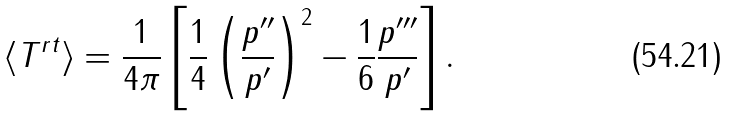<formula> <loc_0><loc_0><loc_500><loc_500>\langle T ^ { r t } \rangle = \frac { 1 } { 4 \pi } \left [ \frac { 1 } { 4 } \left ( \frac { p ^ { \prime \prime } } { p ^ { \prime } } \right ) ^ { 2 } - \frac { 1 } { 6 } \frac { p ^ { \prime \prime \prime } } { p ^ { \prime } } \right ] .</formula> 